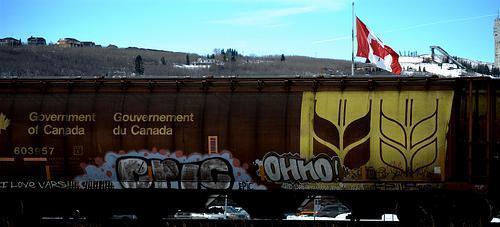How many trains are in the image?
Give a very brief answer. 1. 